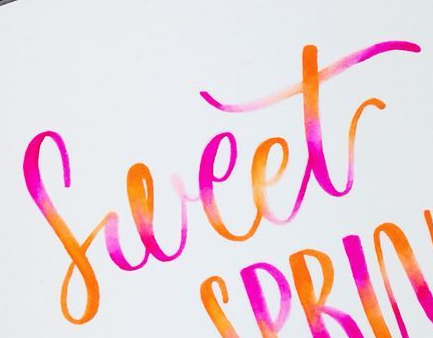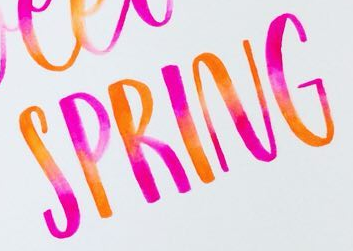What text appears in these images from left to right, separated by a semicolon? Sweet; SPRING 